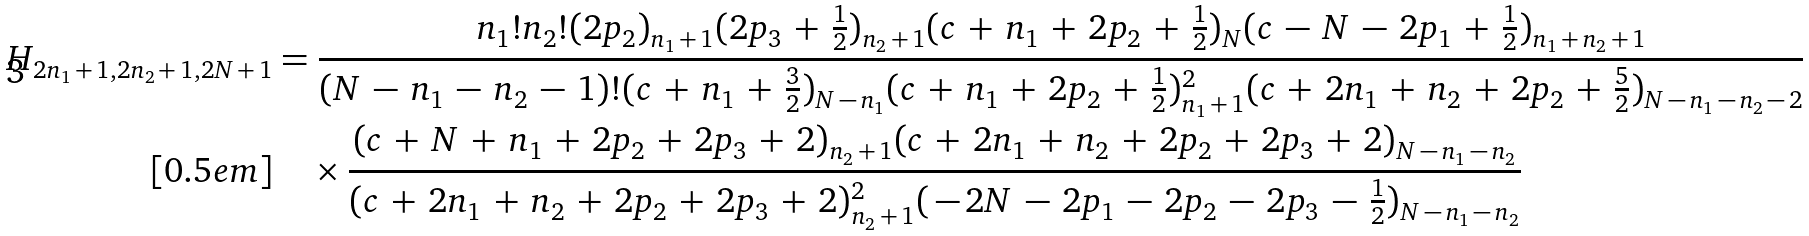Convert formula to latex. <formula><loc_0><loc_0><loc_500><loc_500>H _ { 2 n _ { 1 } \, + \, 1 , 2 n _ { 2 } \, + \, 1 , 2 N \, + \, 1 } & = \frac { n _ { 1 } ! n _ { 2 } ! ( 2 p _ { 2 } ) _ { n _ { 1 } \, + \, 1 } ( 2 p _ { 3 } \, + \, \frac { 1 } { 2 } ) _ { n _ { 2 } \, + \, 1 } ( c \, + \, n _ { 1 } \, + \, 2 p _ { 2 } \, + \, \frac { 1 } { 2 } ) _ { N } ( c \, - \, N \, - \, 2 p _ { 1 } \, + \, \frac { 1 } { 2 } ) _ { n _ { 1 } \, + \, n _ { 2 } \, + \, 1 } } { ( N \, - \, n _ { 1 } \, - \, n _ { 2 } \, - \, 1 ) ! ( c \, + \, n _ { 1 } \, + \, \frac { 3 } { 2 } ) _ { N \, - \, n _ { 1 } } ( c \, + \, n _ { 1 } \, + \, 2 p _ { 2 } \, + \, \frac { 1 } { 2 } ) _ { n _ { 1 } \, + \, 1 } ^ { 2 } ( c \, + \, 2 n _ { 1 } \, + \, n _ { 2 } \, + \, 2 p _ { 2 } \, + \, \frac { 5 } { 2 } ) _ { N \, - \, n _ { 1 } \, - \, n _ { 2 } \, - \, 2 } } \\ [ 0 . 5 e m ] & \quad \times \frac { ( c \, + \, N \, + \, n _ { 1 } \, + \, 2 p _ { 2 } \, + \, 2 p _ { 3 } \, + \, 2 ) _ { n _ { 2 } \, + \, 1 } ( c \, + \, 2 n _ { 1 } \, + \, n _ { 2 } \, + \, 2 p _ { 2 } \, + \, 2 p _ { 3 } \, + \, 2 ) _ { N \, - \, n _ { 1 } \, - \, n _ { 2 } } } { ( c \, + \, 2 n _ { 1 } \, + \, n _ { 2 } \, + \, 2 p _ { 2 } \, + \, 2 p _ { 3 } \, + \, 2 ) _ { n _ { 2 } \, + \, 1 } ^ { 2 } ( \, - \, 2 N \, - \, 2 p _ { 1 } \, - \, 2 p _ { 2 } \, - \, 2 p _ { 3 } \, - \, \frac { 1 } { 2 } ) _ { N \, - \, n _ { 1 } \, - \, n _ { 2 } } }</formula> 